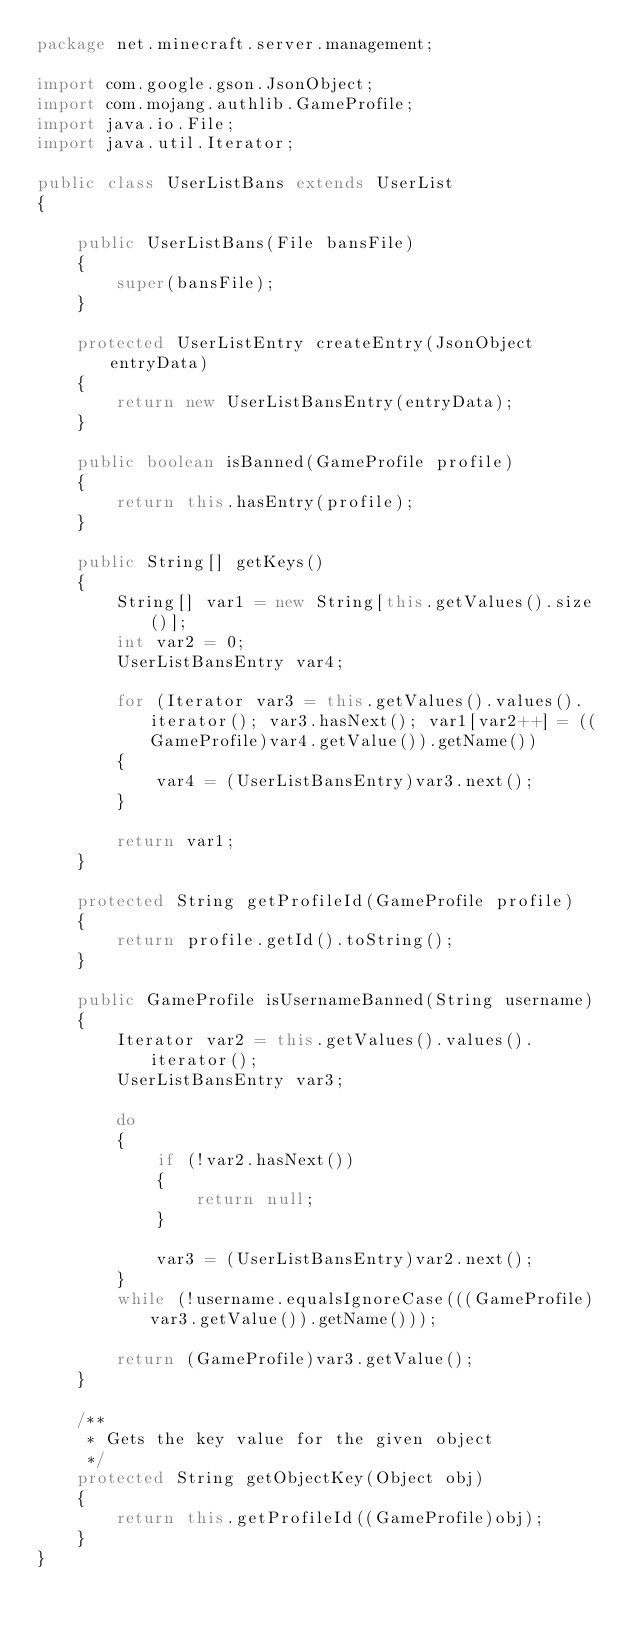<code> <loc_0><loc_0><loc_500><loc_500><_Java_>package net.minecraft.server.management;

import com.google.gson.JsonObject;
import com.mojang.authlib.GameProfile;
import java.io.File;
import java.util.Iterator;

public class UserListBans extends UserList
{

    public UserListBans(File bansFile)
    {
        super(bansFile);
    }

    protected UserListEntry createEntry(JsonObject entryData)
    {
        return new UserListBansEntry(entryData);
    }

    public boolean isBanned(GameProfile profile)
    {
        return this.hasEntry(profile);
    }

    public String[] getKeys()
    {
        String[] var1 = new String[this.getValues().size()];
        int var2 = 0;
        UserListBansEntry var4;

        for (Iterator var3 = this.getValues().values().iterator(); var3.hasNext(); var1[var2++] = ((GameProfile)var4.getValue()).getName())
        {
            var4 = (UserListBansEntry)var3.next();
        }

        return var1;
    }

    protected String getProfileId(GameProfile profile)
    {
        return profile.getId().toString();
    }

    public GameProfile isUsernameBanned(String username)
    {
        Iterator var2 = this.getValues().values().iterator();
        UserListBansEntry var3;

        do
        {
            if (!var2.hasNext())
            {
                return null;
            }

            var3 = (UserListBansEntry)var2.next();
        }
        while (!username.equalsIgnoreCase(((GameProfile)var3.getValue()).getName()));

        return (GameProfile)var3.getValue();
    }

    /**
     * Gets the key value for the given object
     */
    protected String getObjectKey(Object obj)
    {
        return this.getProfileId((GameProfile)obj);
    }
}
</code> 